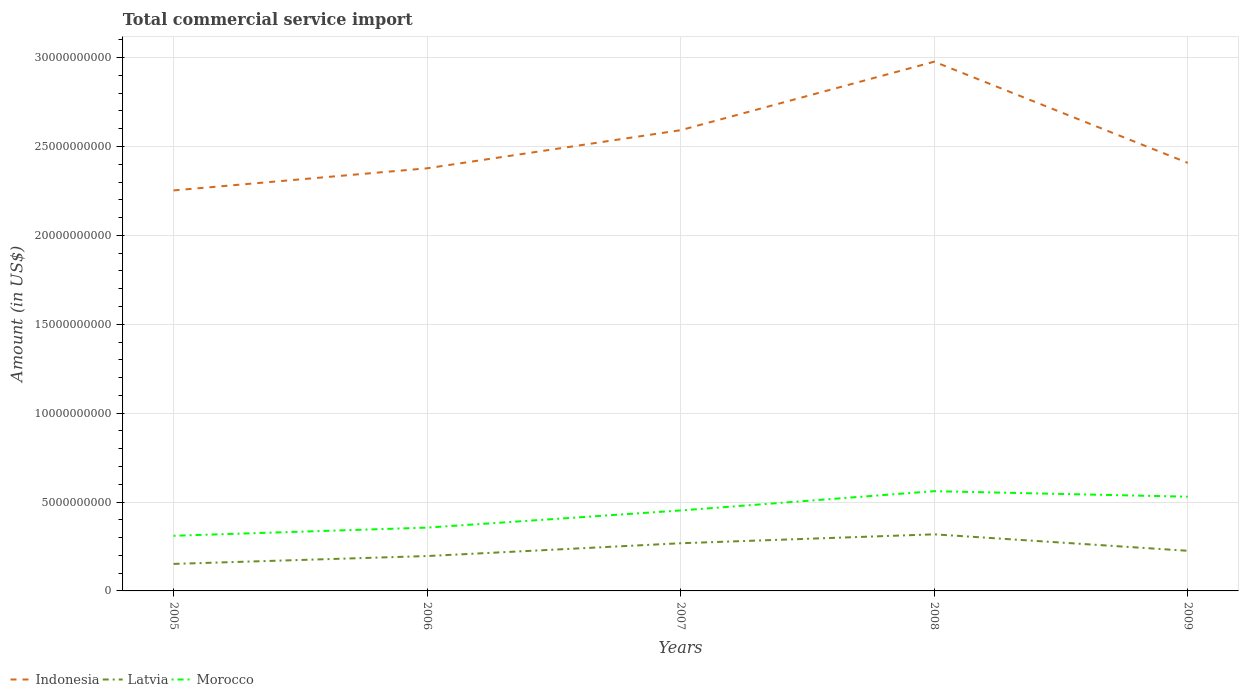Is the number of lines equal to the number of legend labels?
Provide a succinct answer. Yes. Across all years, what is the maximum total commercial service import in Indonesia?
Your answer should be compact. 2.25e+1. What is the total total commercial service import in Latvia in the graph?
Give a very brief answer. -1.16e+09. What is the difference between the highest and the second highest total commercial service import in Morocco?
Provide a succinct answer. 2.51e+09. Is the total commercial service import in Morocco strictly greater than the total commercial service import in Indonesia over the years?
Give a very brief answer. Yes. What is the difference between two consecutive major ticks on the Y-axis?
Provide a succinct answer. 5.00e+09. Does the graph contain grids?
Keep it short and to the point. Yes. How many legend labels are there?
Your response must be concise. 3. What is the title of the graph?
Offer a very short reply. Total commercial service import. What is the label or title of the X-axis?
Provide a short and direct response. Years. What is the Amount (in US$) of Indonesia in 2005?
Provide a succinct answer. 2.25e+1. What is the Amount (in US$) of Latvia in 2005?
Offer a very short reply. 1.52e+09. What is the Amount (in US$) in Morocco in 2005?
Keep it short and to the point. 3.10e+09. What is the Amount (in US$) of Indonesia in 2006?
Keep it short and to the point. 2.38e+1. What is the Amount (in US$) in Latvia in 2006?
Offer a terse response. 1.96e+09. What is the Amount (in US$) in Morocco in 2006?
Offer a terse response. 3.56e+09. What is the Amount (in US$) in Indonesia in 2007?
Provide a succinct answer. 2.59e+1. What is the Amount (in US$) of Latvia in 2007?
Provide a short and direct response. 2.68e+09. What is the Amount (in US$) of Morocco in 2007?
Offer a terse response. 4.53e+09. What is the Amount (in US$) of Indonesia in 2008?
Your response must be concise. 2.98e+1. What is the Amount (in US$) in Latvia in 2008?
Offer a terse response. 3.18e+09. What is the Amount (in US$) of Morocco in 2008?
Your answer should be compact. 5.61e+09. What is the Amount (in US$) of Indonesia in 2009?
Your answer should be compact. 2.41e+1. What is the Amount (in US$) of Latvia in 2009?
Provide a short and direct response. 2.26e+09. What is the Amount (in US$) in Morocco in 2009?
Provide a short and direct response. 5.30e+09. Across all years, what is the maximum Amount (in US$) of Indonesia?
Keep it short and to the point. 2.98e+1. Across all years, what is the maximum Amount (in US$) in Latvia?
Your answer should be compact. 3.18e+09. Across all years, what is the maximum Amount (in US$) in Morocco?
Provide a succinct answer. 5.61e+09. Across all years, what is the minimum Amount (in US$) in Indonesia?
Provide a succinct answer. 2.25e+1. Across all years, what is the minimum Amount (in US$) of Latvia?
Your answer should be very brief. 1.52e+09. Across all years, what is the minimum Amount (in US$) in Morocco?
Your answer should be compact. 3.10e+09. What is the total Amount (in US$) in Indonesia in the graph?
Offer a terse response. 1.26e+11. What is the total Amount (in US$) in Latvia in the graph?
Offer a very short reply. 1.16e+1. What is the total Amount (in US$) in Morocco in the graph?
Provide a short and direct response. 2.21e+1. What is the difference between the Amount (in US$) in Indonesia in 2005 and that in 2006?
Keep it short and to the point. -1.24e+09. What is the difference between the Amount (in US$) of Latvia in 2005 and that in 2006?
Keep it short and to the point. -4.42e+08. What is the difference between the Amount (in US$) in Morocco in 2005 and that in 2006?
Your answer should be very brief. -4.59e+08. What is the difference between the Amount (in US$) in Indonesia in 2005 and that in 2007?
Give a very brief answer. -3.39e+09. What is the difference between the Amount (in US$) in Latvia in 2005 and that in 2007?
Your response must be concise. -1.16e+09. What is the difference between the Amount (in US$) of Morocco in 2005 and that in 2007?
Your answer should be very brief. -1.42e+09. What is the difference between the Amount (in US$) of Indonesia in 2005 and that in 2008?
Ensure brevity in your answer.  -7.24e+09. What is the difference between the Amount (in US$) in Latvia in 2005 and that in 2008?
Give a very brief answer. -1.66e+09. What is the difference between the Amount (in US$) of Morocco in 2005 and that in 2008?
Your answer should be very brief. -2.51e+09. What is the difference between the Amount (in US$) of Indonesia in 2005 and that in 2009?
Offer a very short reply. -1.55e+09. What is the difference between the Amount (in US$) of Latvia in 2005 and that in 2009?
Provide a succinct answer. -7.38e+08. What is the difference between the Amount (in US$) in Morocco in 2005 and that in 2009?
Offer a very short reply. -2.20e+09. What is the difference between the Amount (in US$) in Indonesia in 2006 and that in 2007?
Offer a very short reply. -2.14e+09. What is the difference between the Amount (in US$) in Latvia in 2006 and that in 2007?
Provide a succinct answer. -7.20e+08. What is the difference between the Amount (in US$) of Morocco in 2006 and that in 2007?
Provide a short and direct response. -9.66e+08. What is the difference between the Amount (in US$) in Indonesia in 2006 and that in 2008?
Keep it short and to the point. -6.00e+09. What is the difference between the Amount (in US$) in Latvia in 2006 and that in 2008?
Your answer should be very brief. -1.22e+09. What is the difference between the Amount (in US$) in Morocco in 2006 and that in 2008?
Your answer should be very brief. -2.05e+09. What is the difference between the Amount (in US$) in Indonesia in 2006 and that in 2009?
Ensure brevity in your answer.  -3.04e+08. What is the difference between the Amount (in US$) in Latvia in 2006 and that in 2009?
Keep it short and to the point. -2.96e+08. What is the difference between the Amount (in US$) in Morocco in 2006 and that in 2009?
Offer a very short reply. -1.74e+09. What is the difference between the Amount (in US$) of Indonesia in 2007 and that in 2008?
Give a very brief answer. -3.85e+09. What is the difference between the Amount (in US$) of Latvia in 2007 and that in 2008?
Offer a very short reply. -5.02e+08. What is the difference between the Amount (in US$) in Morocco in 2007 and that in 2008?
Offer a terse response. -1.08e+09. What is the difference between the Amount (in US$) of Indonesia in 2007 and that in 2009?
Your answer should be compact. 1.84e+09. What is the difference between the Amount (in US$) in Latvia in 2007 and that in 2009?
Make the answer very short. 4.24e+08. What is the difference between the Amount (in US$) of Morocco in 2007 and that in 2009?
Give a very brief answer. -7.74e+08. What is the difference between the Amount (in US$) in Indonesia in 2008 and that in 2009?
Provide a short and direct response. 5.69e+09. What is the difference between the Amount (in US$) of Latvia in 2008 and that in 2009?
Your answer should be very brief. 9.26e+08. What is the difference between the Amount (in US$) of Morocco in 2008 and that in 2009?
Ensure brevity in your answer.  3.11e+08. What is the difference between the Amount (in US$) of Indonesia in 2005 and the Amount (in US$) of Latvia in 2006?
Provide a short and direct response. 2.06e+1. What is the difference between the Amount (in US$) in Indonesia in 2005 and the Amount (in US$) in Morocco in 2006?
Make the answer very short. 1.90e+1. What is the difference between the Amount (in US$) in Latvia in 2005 and the Amount (in US$) in Morocco in 2006?
Give a very brief answer. -2.04e+09. What is the difference between the Amount (in US$) in Indonesia in 2005 and the Amount (in US$) in Latvia in 2007?
Make the answer very short. 1.98e+1. What is the difference between the Amount (in US$) in Indonesia in 2005 and the Amount (in US$) in Morocco in 2007?
Your answer should be very brief. 1.80e+1. What is the difference between the Amount (in US$) of Latvia in 2005 and the Amount (in US$) of Morocco in 2007?
Ensure brevity in your answer.  -3.01e+09. What is the difference between the Amount (in US$) of Indonesia in 2005 and the Amount (in US$) of Latvia in 2008?
Provide a succinct answer. 1.93e+1. What is the difference between the Amount (in US$) in Indonesia in 2005 and the Amount (in US$) in Morocco in 2008?
Your response must be concise. 1.69e+1. What is the difference between the Amount (in US$) in Latvia in 2005 and the Amount (in US$) in Morocco in 2008?
Your response must be concise. -4.09e+09. What is the difference between the Amount (in US$) of Indonesia in 2005 and the Amount (in US$) of Latvia in 2009?
Give a very brief answer. 2.03e+1. What is the difference between the Amount (in US$) of Indonesia in 2005 and the Amount (in US$) of Morocco in 2009?
Make the answer very short. 1.72e+1. What is the difference between the Amount (in US$) of Latvia in 2005 and the Amount (in US$) of Morocco in 2009?
Offer a very short reply. -3.78e+09. What is the difference between the Amount (in US$) in Indonesia in 2006 and the Amount (in US$) in Latvia in 2007?
Offer a terse response. 2.11e+1. What is the difference between the Amount (in US$) of Indonesia in 2006 and the Amount (in US$) of Morocco in 2007?
Offer a terse response. 1.92e+1. What is the difference between the Amount (in US$) of Latvia in 2006 and the Amount (in US$) of Morocco in 2007?
Make the answer very short. -2.57e+09. What is the difference between the Amount (in US$) of Indonesia in 2006 and the Amount (in US$) of Latvia in 2008?
Offer a very short reply. 2.06e+1. What is the difference between the Amount (in US$) of Indonesia in 2006 and the Amount (in US$) of Morocco in 2008?
Keep it short and to the point. 1.82e+1. What is the difference between the Amount (in US$) of Latvia in 2006 and the Amount (in US$) of Morocco in 2008?
Provide a short and direct response. -3.65e+09. What is the difference between the Amount (in US$) of Indonesia in 2006 and the Amount (in US$) of Latvia in 2009?
Your answer should be compact. 2.15e+1. What is the difference between the Amount (in US$) in Indonesia in 2006 and the Amount (in US$) in Morocco in 2009?
Give a very brief answer. 1.85e+1. What is the difference between the Amount (in US$) of Latvia in 2006 and the Amount (in US$) of Morocco in 2009?
Ensure brevity in your answer.  -3.34e+09. What is the difference between the Amount (in US$) in Indonesia in 2007 and the Amount (in US$) in Latvia in 2008?
Your answer should be compact. 2.27e+1. What is the difference between the Amount (in US$) of Indonesia in 2007 and the Amount (in US$) of Morocco in 2008?
Give a very brief answer. 2.03e+1. What is the difference between the Amount (in US$) of Latvia in 2007 and the Amount (in US$) of Morocco in 2008?
Offer a terse response. -2.93e+09. What is the difference between the Amount (in US$) of Indonesia in 2007 and the Amount (in US$) of Latvia in 2009?
Provide a short and direct response. 2.37e+1. What is the difference between the Amount (in US$) in Indonesia in 2007 and the Amount (in US$) in Morocco in 2009?
Your response must be concise. 2.06e+1. What is the difference between the Amount (in US$) of Latvia in 2007 and the Amount (in US$) of Morocco in 2009?
Your response must be concise. -2.62e+09. What is the difference between the Amount (in US$) of Indonesia in 2008 and the Amount (in US$) of Latvia in 2009?
Keep it short and to the point. 2.75e+1. What is the difference between the Amount (in US$) in Indonesia in 2008 and the Amount (in US$) in Morocco in 2009?
Give a very brief answer. 2.45e+1. What is the difference between the Amount (in US$) in Latvia in 2008 and the Amount (in US$) in Morocco in 2009?
Your answer should be compact. -2.12e+09. What is the average Amount (in US$) in Indonesia per year?
Offer a terse response. 2.52e+1. What is the average Amount (in US$) in Latvia per year?
Provide a succinct answer. 2.32e+09. What is the average Amount (in US$) of Morocco per year?
Ensure brevity in your answer.  4.42e+09. In the year 2005, what is the difference between the Amount (in US$) of Indonesia and Amount (in US$) of Latvia?
Make the answer very short. 2.10e+1. In the year 2005, what is the difference between the Amount (in US$) of Indonesia and Amount (in US$) of Morocco?
Your response must be concise. 1.94e+1. In the year 2005, what is the difference between the Amount (in US$) of Latvia and Amount (in US$) of Morocco?
Give a very brief answer. -1.58e+09. In the year 2006, what is the difference between the Amount (in US$) in Indonesia and Amount (in US$) in Latvia?
Keep it short and to the point. 2.18e+1. In the year 2006, what is the difference between the Amount (in US$) in Indonesia and Amount (in US$) in Morocco?
Make the answer very short. 2.02e+1. In the year 2006, what is the difference between the Amount (in US$) of Latvia and Amount (in US$) of Morocco?
Give a very brief answer. -1.60e+09. In the year 2007, what is the difference between the Amount (in US$) of Indonesia and Amount (in US$) of Latvia?
Offer a terse response. 2.32e+1. In the year 2007, what is the difference between the Amount (in US$) in Indonesia and Amount (in US$) in Morocco?
Your response must be concise. 2.14e+1. In the year 2007, what is the difference between the Amount (in US$) of Latvia and Amount (in US$) of Morocco?
Your response must be concise. -1.85e+09. In the year 2008, what is the difference between the Amount (in US$) of Indonesia and Amount (in US$) of Latvia?
Make the answer very short. 2.66e+1. In the year 2008, what is the difference between the Amount (in US$) of Indonesia and Amount (in US$) of Morocco?
Give a very brief answer. 2.42e+1. In the year 2008, what is the difference between the Amount (in US$) in Latvia and Amount (in US$) in Morocco?
Provide a short and direct response. -2.43e+09. In the year 2009, what is the difference between the Amount (in US$) of Indonesia and Amount (in US$) of Latvia?
Offer a terse response. 2.18e+1. In the year 2009, what is the difference between the Amount (in US$) of Indonesia and Amount (in US$) of Morocco?
Offer a very short reply. 1.88e+1. In the year 2009, what is the difference between the Amount (in US$) in Latvia and Amount (in US$) in Morocco?
Your answer should be very brief. -3.04e+09. What is the ratio of the Amount (in US$) in Indonesia in 2005 to that in 2006?
Make the answer very short. 0.95. What is the ratio of the Amount (in US$) of Latvia in 2005 to that in 2006?
Give a very brief answer. 0.77. What is the ratio of the Amount (in US$) of Morocco in 2005 to that in 2006?
Ensure brevity in your answer.  0.87. What is the ratio of the Amount (in US$) in Indonesia in 2005 to that in 2007?
Keep it short and to the point. 0.87. What is the ratio of the Amount (in US$) of Latvia in 2005 to that in 2007?
Offer a terse response. 0.57. What is the ratio of the Amount (in US$) of Morocco in 2005 to that in 2007?
Make the answer very short. 0.69. What is the ratio of the Amount (in US$) of Indonesia in 2005 to that in 2008?
Your answer should be very brief. 0.76. What is the ratio of the Amount (in US$) of Latvia in 2005 to that in 2008?
Offer a terse response. 0.48. What is the ratio of the Amount (in US$) of Morocco in 2005 to that in 2008?
Your response must be concise. 0.55. What is the ratio of the Amount (in US$) in Indonesia in 2005 to that in 2009?
Your answer should be compact. 0.94. What is the ratio of the Amount (in US$) of Latvia in 2005 to that in 2009?
Provide a succinct answer. 0.67. What is the ratio of the Amount (in US$) of Morocco in 2005 to that in 2009?
Provide a short and direct response. 0.59. What is the ratio of the Amount (in US$) of Indonesia in 2006 to that in 2007?
Make the answer very short. 0.92. What is the ratio of the Amount (in US$) of Latvia in 2006 to that in 2007?
Give a very brief answer. 0.73. What is the ratio of the Amount (in US$) in Morocco in 2006 to that in 2007?
Make the answer very short. 0.79. What is the ratio of the Amount (in US$) in Indonesia in 2006 to that in 2008?
Your answer should be very brief. 0.8. What is the ratio of the Amount (in US$) of Latvia in 2006 to that in 2008?
Your answer should be very brief. 0.62. What is the ratio of the Amount (in US$) of Morocco in 2006 to that in 2008?
Ensure brevity in your answer.  0.63. What is the ratio of the Amount (in US$) of Indonesia in 2006 to that in 2009?
Ensure brevity in your answer.  0.99. What is the ratio of the Amount (in US$) of Latvia in 2006 to that in 2009?
Ensure brevity in your answer.  0.87. What is the ratio of the Amount (in US$) of Morocco in 2006 to that in 2009?
Make the answer very short. 0.67. What is the ratio of the Amount (in US$) of Indonesia in 2007 to that in 2008?
Your answer should be compact. 0.87. What is the ratio of the Amount (in US$) in Latvia in 2007 to that in 2008?
Your answer should be compact. 0.84. What is the ratio of the Amount (in US$) in Morocco in 2007 to that in 2008?
Offer a very short reply. 0.81. What is the ratio of the Amount (in US$) of Indonesia in 2007 to that in 2009?
Offer a very short reply. 1.08. What is the ratio of the Amount (in US$) in Latvia in 2007 to that in 2009?
Your answer should be compact. 1.19. What is the ratio of the Amount (in US$) in Morocco in 2007 to that in 2009?
Ensure brevity in your answer.  0.85. What is the ratio of the Amount (in US$) of Indonesia in 2008 to that in 2009?
Provide a succinct answer. 1.24. What is the ratio of the Amount (in US$) of Latvia in 2008 to that in 2009?
Offer a terse response. 1.41. What is the ratio of the Amount (in US$) of Morocco in 2008 to that in 2009?
Your response must be concise. 1.06. What is the difference between the highest and the second highest Amount (in US$) in Indonesia?
Make the answer very short. 3.85e+09. What is the difference between the highest and the second highest Amount (in US$) of Latvia?
Your answer should be compact. 5.02e+08. What is the difference between the highest and the second highest Amount (in US$) in Morocco?
Provide a succinct answer. 3.11e+08. What is the difference between the highest and the lowest Amount (in US$) in Indonesia?
Provide a short and direct response. 7.24e+09. What is the difference between the highest and the lowest Amount (in US$) of Latvia?
Give a very brief answer. 1.66e+09. What is the difference between the highest and the lowest Amount (in US$) in Morocco?
Offer a terse response. 2.51e+09. 